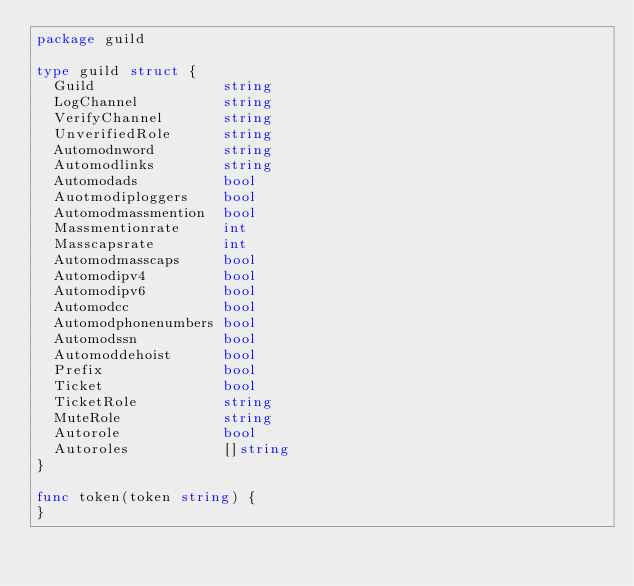<code> <loc_0><loc_0><loc_500><loc_500><_Go_>package guild

type guild struct {
	Guild               string
	LogChannel          string
	VerifyChannel       string
	UnverifiedRole      string
	Automodnword        string
	Automodlinks        string
	Automodads          bool
	Auotmodiploggers    bool
	Automodmassmention  bool
	Massmentionrate     int
	Masscapsrate        int
	Automodmasscaps     bool
	Automodipv4         bool
	Automodipv6         bool
	Automodcc           bool
	Automodphonenumbers bool
	Automodssn          bool
	Automoddehoist      bool
	Prefix              bool
	Ticket              bool
	TicketRole          string
	MuteRole            string
	Autorole            bool
	Autoroles           []string
}

func token(token string) {
}
</code> 